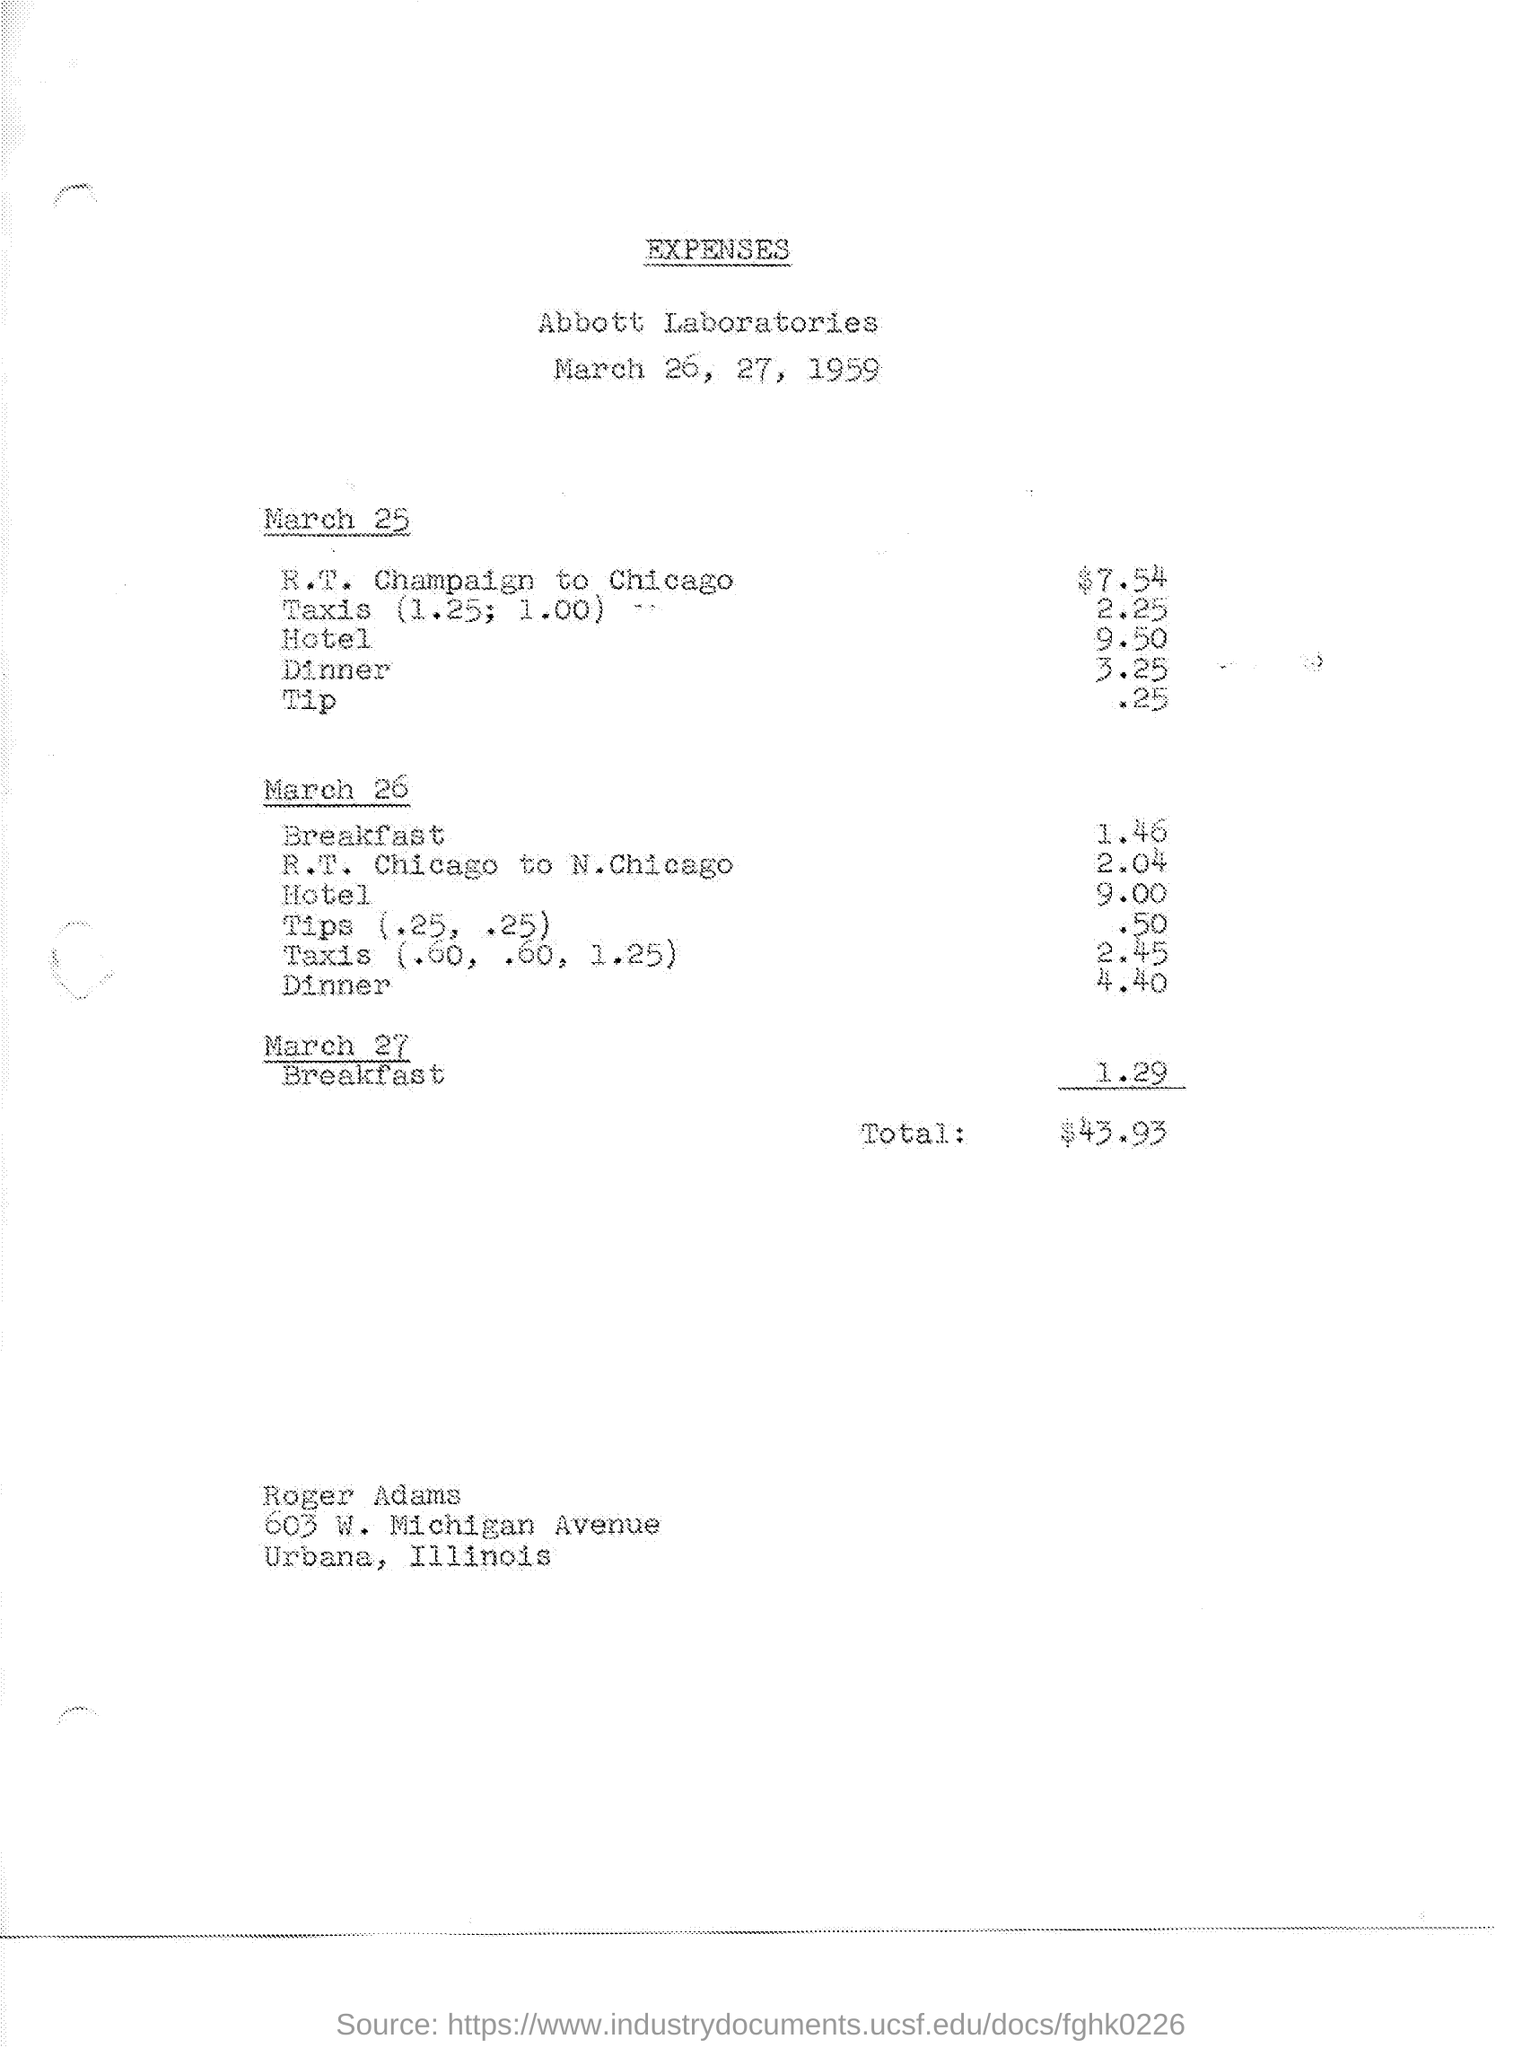What is the name of the laboratories mentioned in the given page ?
Provide a short and direct response. Abbott laboratories. What are the expenses for r.t. champaign to chicago on march 25?
Make the answer very short. $ 7.54. What are the expenses towards taxis on march 25?
Keep it short and to the point. 2.25. What are the expenses towards dinner on march 25 ?
Provide a short and direct response. 3.25. What are the expenses towards hotel on march 25 ?
Keep it short and to the point. 9.50. What are the expenses towards breakfast on march 26 ?
Your response must be concise. 1.46. What are the expenses for r.t. champaign to  n.chicago on march 26?
Your answer should be very brief. 2.04. What are the expenses towards dinner on march 26 ?
Give a very brief answer. 4.40. What are the expenses towards breakfast on march 27 ?
Your answer should be compact. 1.29. What is the amount of total expenses shown in the given page ?
Make the answer very short. $43.93. 